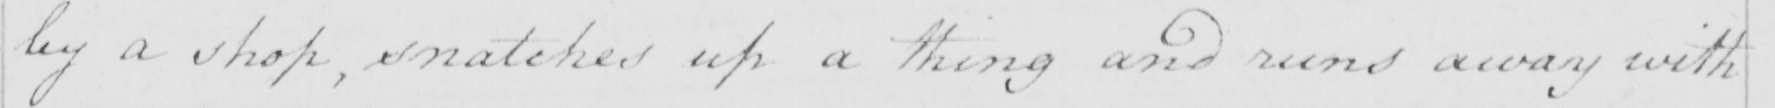What does this handwritten line say? by a shop , snatches up a thing and runs away with 